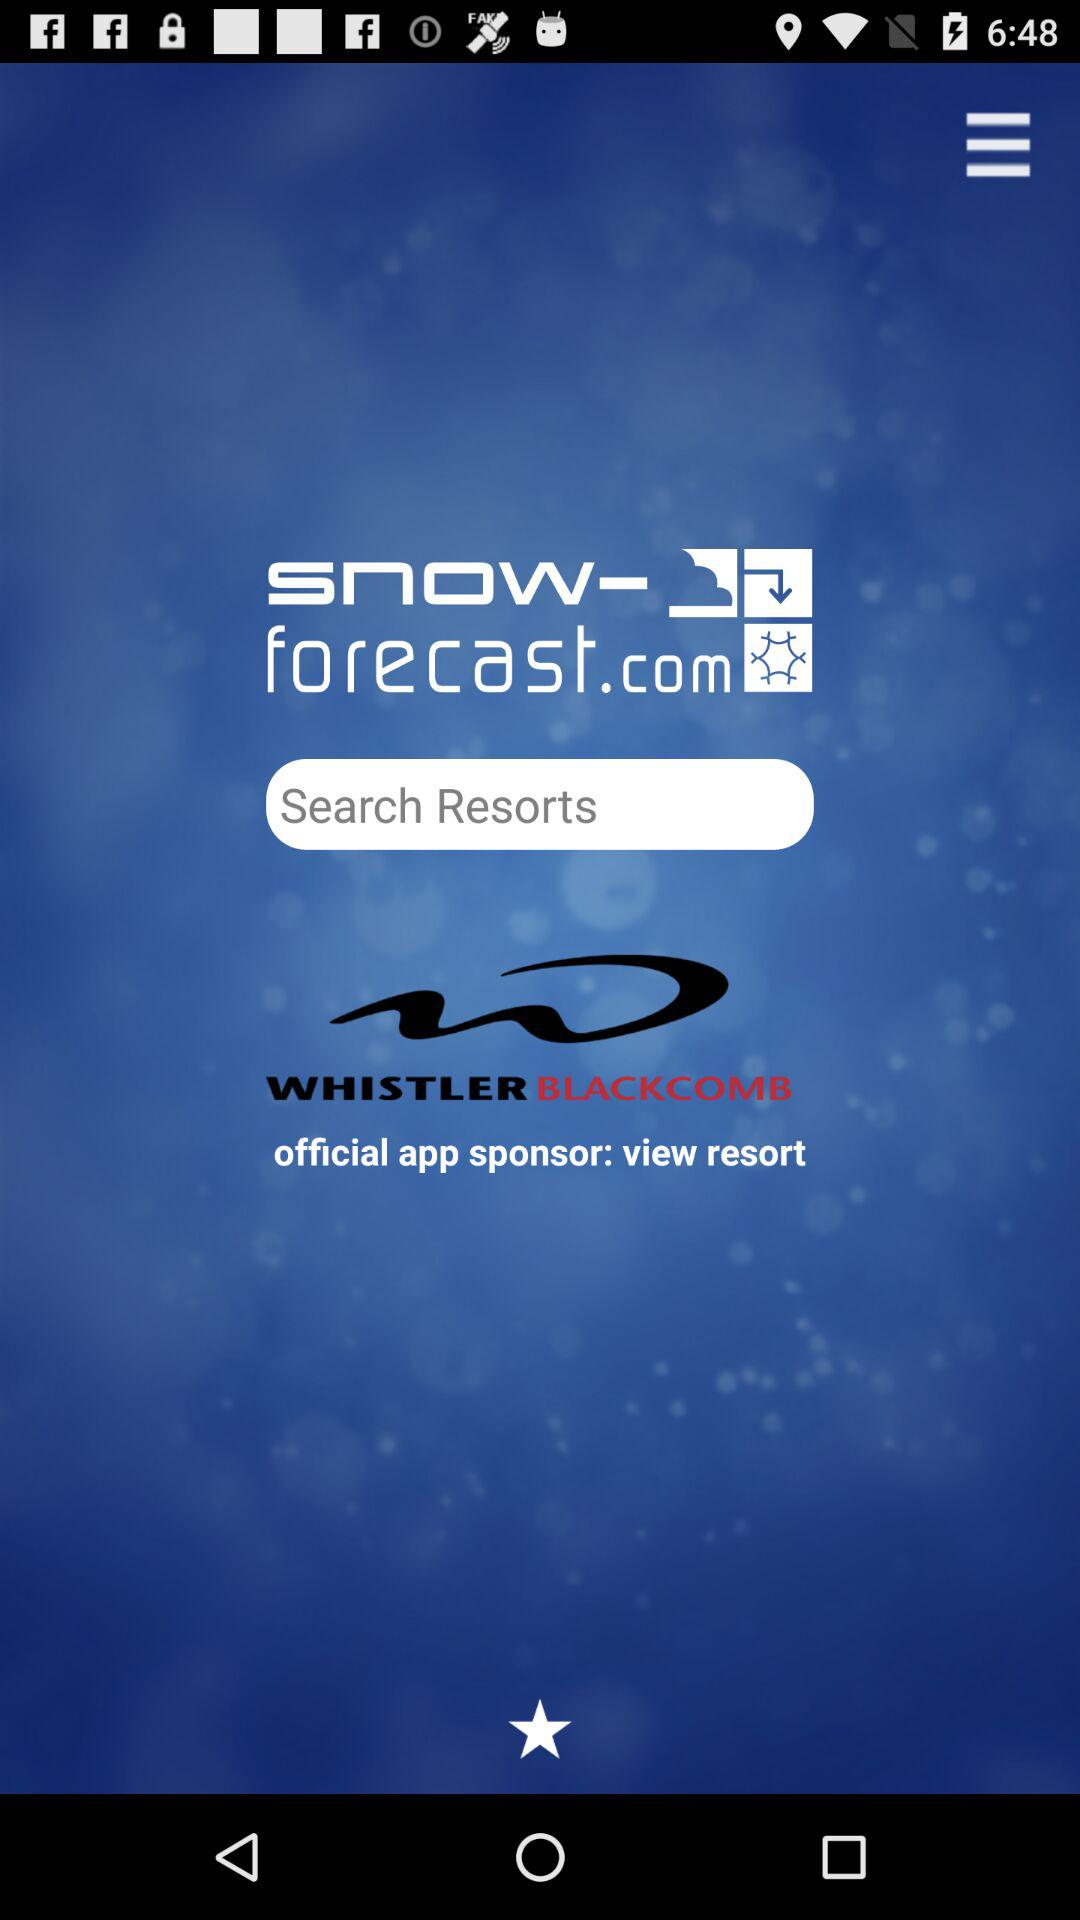Who is the official app sponsor? The official app sponsor is "view resort". 